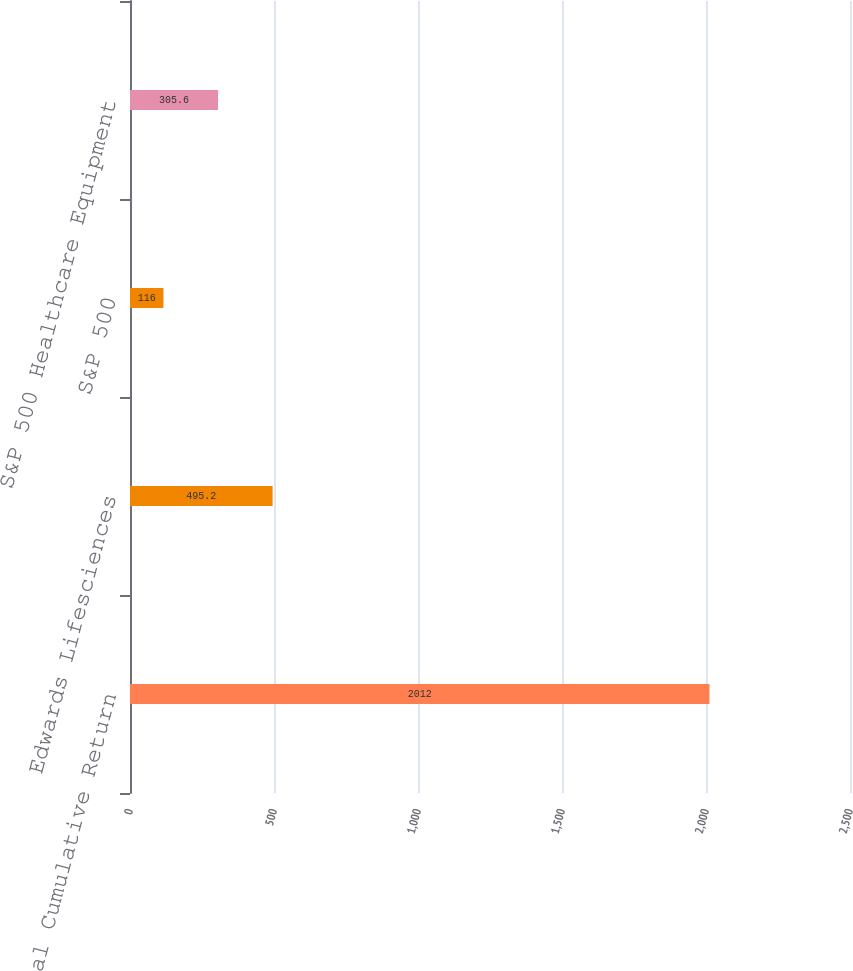<chart> <loc_0><loc_0><loc_500><loc_500><bar_chart><fcel>Total Cumulative Return<fcel>Edwards Lifesciences<fcel>S&P 500<fcel>S&P 500 Healthcare Equipment<nl><fcel>2012<fcel>495.2<fcel>116<fcel>305.6<nl></chart> 